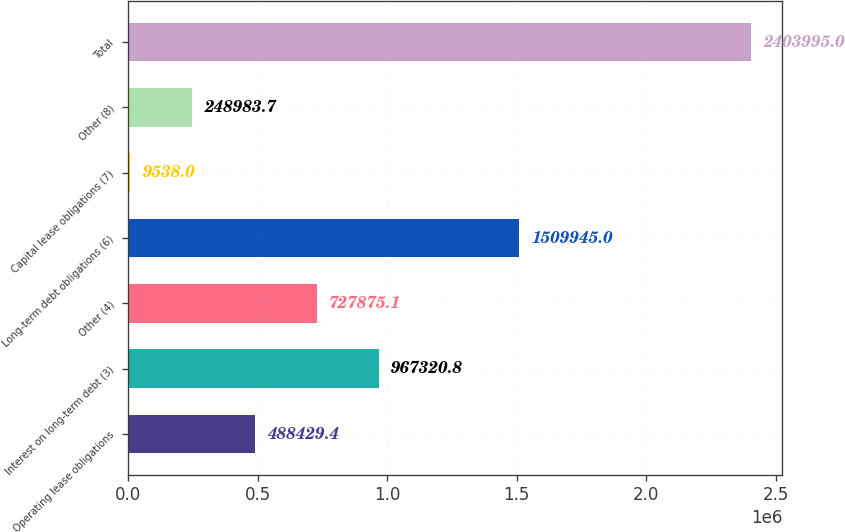<chart> <loc_0><loc_0><loc_500><loc_500><bar_chart><fcel>Operating lease obligations<fcel>Interest on long-term debt (3)<fcel>Other (4)<fcel>Long-term debt obligations (6)<fcel>Capital lease obligations (7)<fcel>Other (8)<fcel>Total<nl><fcel>488429<fcel>967321<fcel>727875<fcel>1.50994e+06<fcel>9538<fcel>248984<fcel>2.404e+06<nl></chart> 